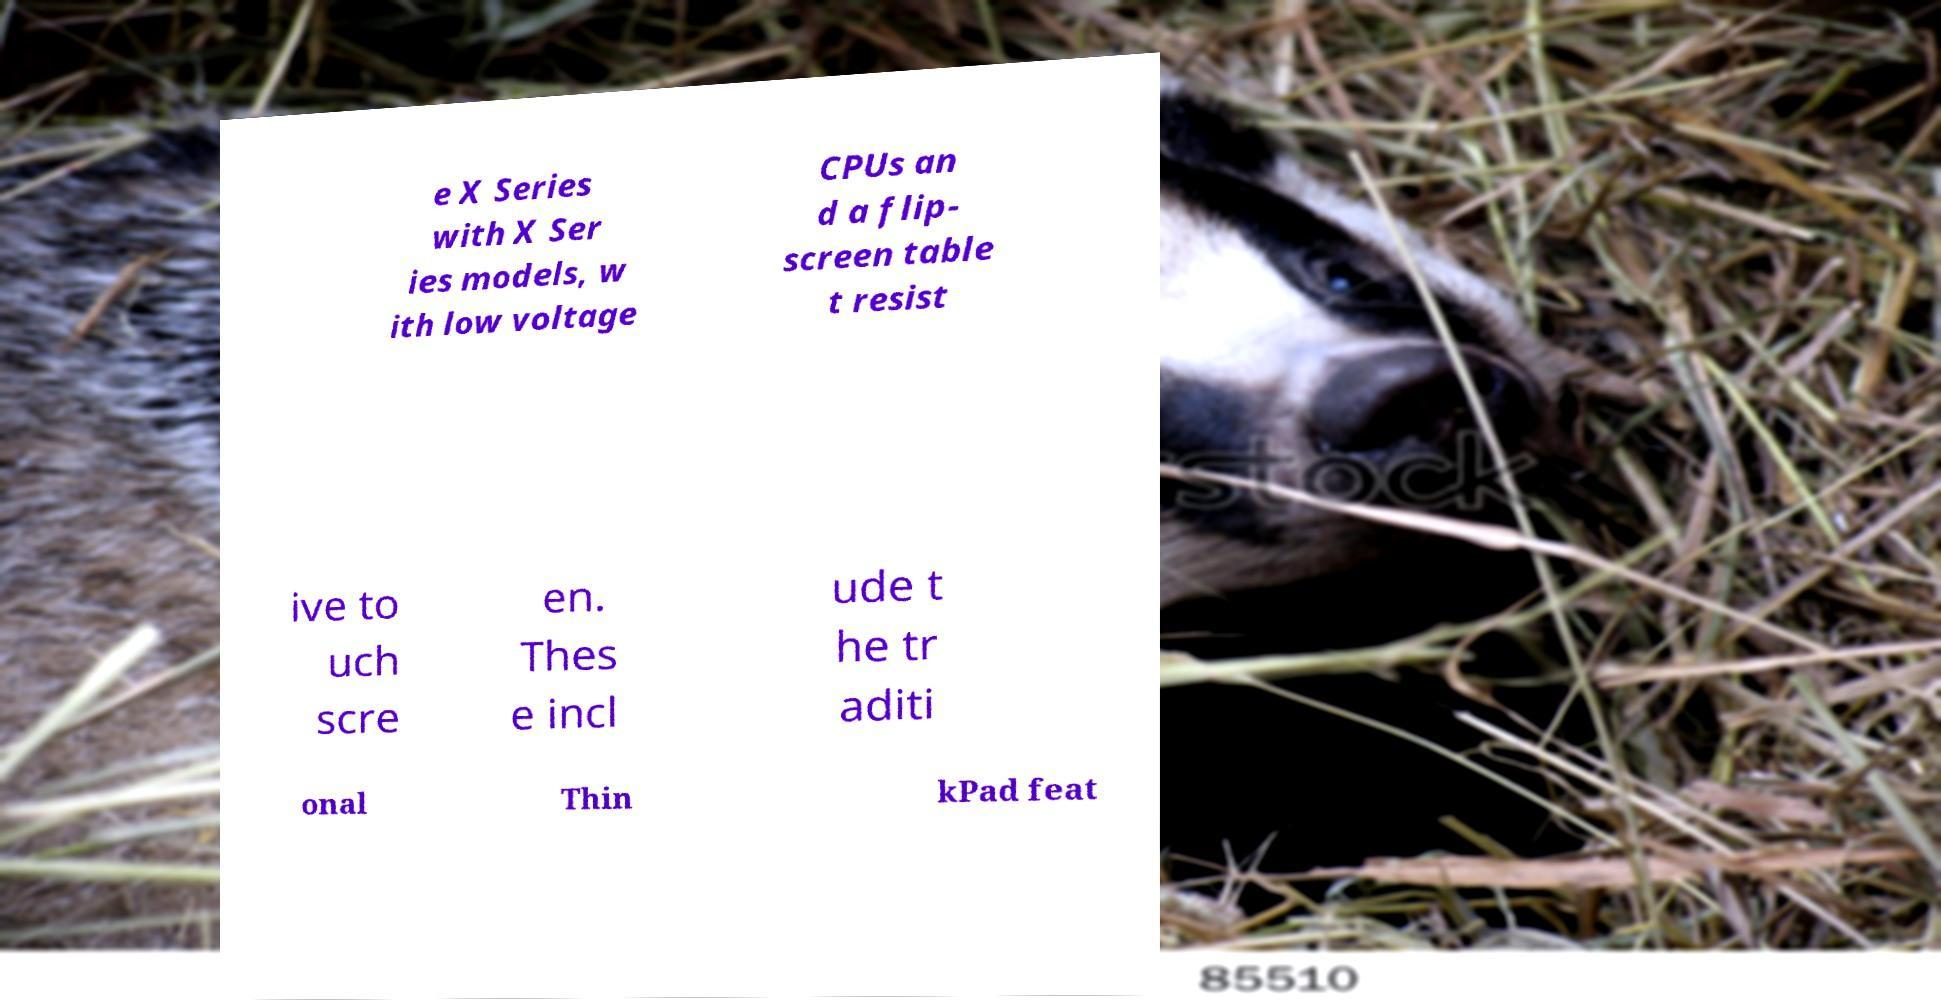There's text embedded in this image that I need extracted. Can you transcribe it verbatim? e X Series with X Ser ies models, w ith low voltage CPUs an d a flip- screen table t resist ive to uch scre en. Thes e incl ude t he tr aditi onal Thin kPad feat 